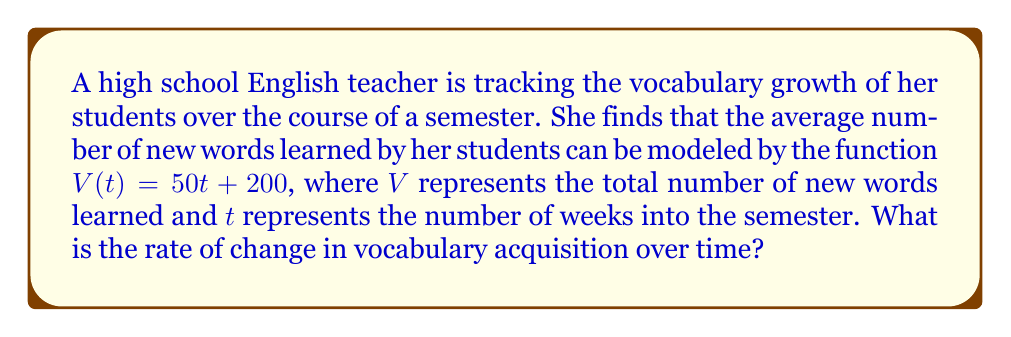Could you help me with this problem? To determine the rate of change in vocabulary acquisition over time, we need to find the slope of the given function $V(t) = 50t + 200$.

Step 1: Identify the general form of a linear function.
The general form of a linear function is $f(x) = mx + b$, where $m$ is the slope (rate of change) and $b$ is the y-intercept.

Step 2: Compare the given function to the general form.
$V(t) = 50t + 200$

We can see that:
- $t$ corresponds to $x$ (the independent variable)
- $50$ corresponds to $m$ (the slope)
- $200$ corresponds to $b$ (the y-intercept)

Step 3: Interpret the slope.
The slope, $m = 50$, represents the rate of change in vocabulary acquisition over time.

This means that for each unit increase in $t$ (one week), $V$ increases by 50 words.

Therefore, the rate of change in vocabulary acquisition is 50 words per week.
Answer: 50 words per week 